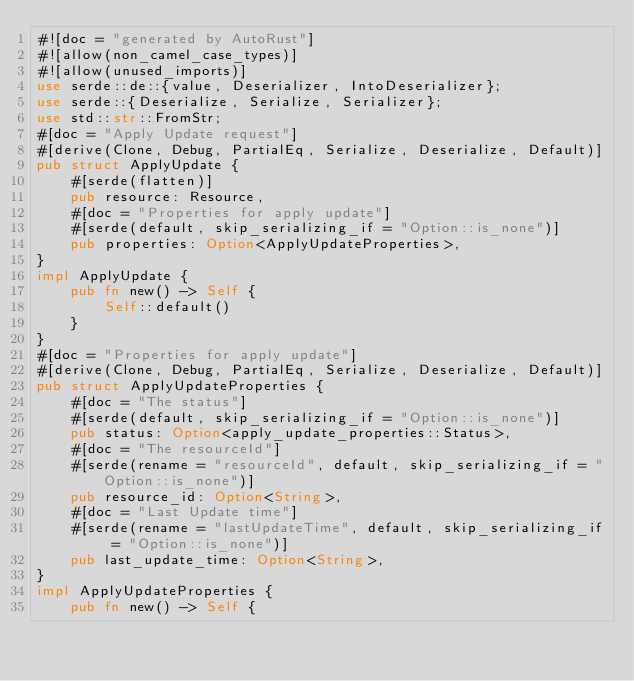Convert code to text. <code><loc_0><loc_0><loc_500><loc_500><_Rust_>#![doc = "generated by AutoRust"]
#![allow(non_camel_case_types)]
#![allow(unused_imports)]
use serde::de::{value, Deserializer, IntoDeserializer};
use serde::{Deserialize, Serialize, Serializer};
use std::str::FromStr;
#[doc = "Apply Update request"]
#[derive(Clone, Debug, PartialEq, Serialize, Deserialize, Default)]
pub struct ApplyUpdate {
    #[serde(flatten)]
    pub resource: Resource,
    #[doc = "Properties for apply update"]
    #[serde(default, skip_serializing_if = "Option::is_none")]
    pub properties: Option<ApplyUpdateProperties>,
}
impl ApplyUpdate {
    pub fn new() -> Self {
        Self::default()
    }
}
#[doc = "Properties for apply update"]
#[derive(Clone, Debug, PartialEq, Serialize, Deserialize, Default)]
pub struct ApplyUpdateProperties {
    #[doc = "The status"]
    #[serde(default, skip_serializing_if = "Option::is_none")]
    pub status: Option<apply_update_properties::Status>,
    #[doc = "The resourceId"]
    #[serde(rename = "resourceId", default, skip_serializing_if = "Option::is_none")]
    pub resource_id: Option<String>,
    #[doc = "Last Update time"]
    #[serde(rename = "lastUpdateTime", default, skip_serializing_if = "Option::is_none")]
    pub last_update_time: Option<String>,
}
impl ApplyUpdateProperties {
    pub fn new() -> Self {</code> 